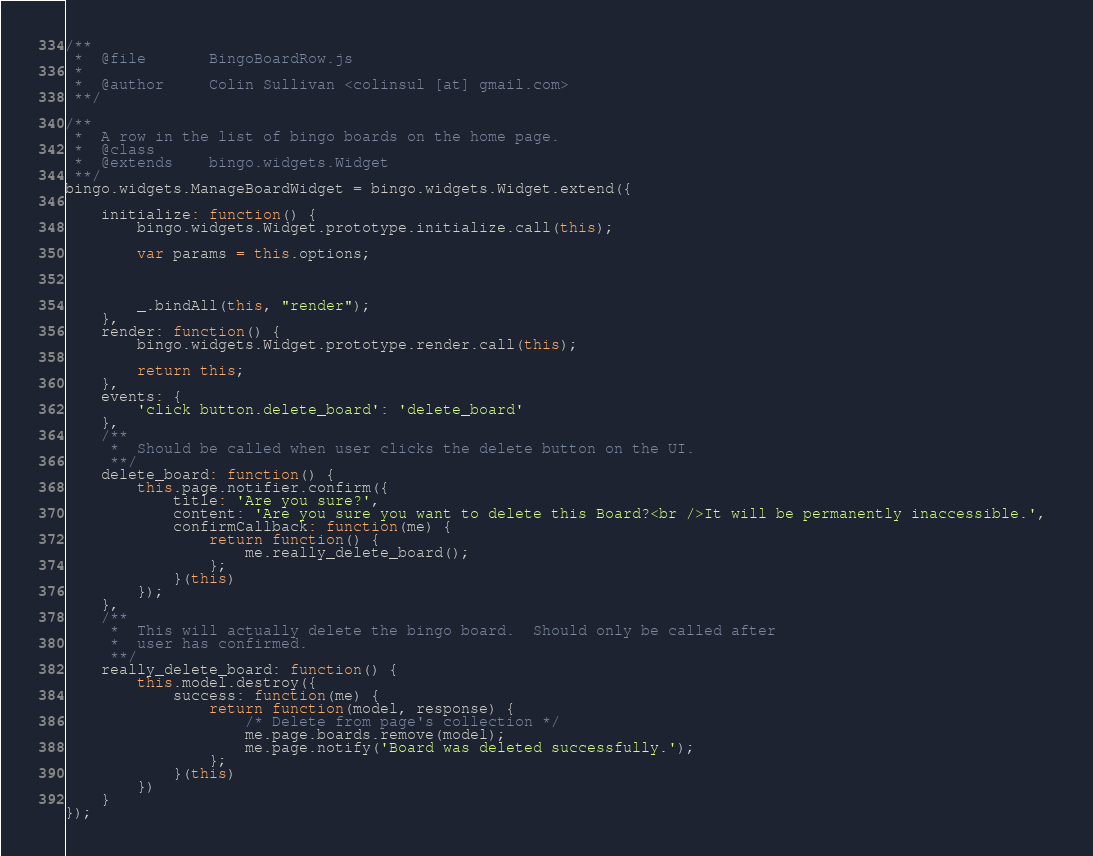Convert code to text. <code><loc_0><loc_0><loc_500><loc_500><_JavaScript_>/**
 *  @file       BingoBoardRow.js
 *  
 *  @author     Colin Sullivan <colinsul [at] gmail.com>
 **/
 
/**
 *  A row in the list of bingo boards on the home page.
 *  @class
 *  @extends    bingo.widgets.Widget
 **/
bingo.widgets.ManageBoardWidget = bingo.widgets.Widget.extend({
    
    initialize: function() {
        bingo.widgets.Widget.prototype.initialize.call(this);

        var params = this.options;
        
        

        _.bindAll(this, "render");
    },
    render: function() {
        bingo.widgets.Widget.prototype.render.call(this);
        
        return this;
    },
    events: {
        'click button.delete_board': 'delete_board'
    }, 
    /**
     *  Should be called when user clicks the delete button on the UI.
     **/
    delete_board: function() {
        this.page.notifier.confirm({
            title: 'Are you sure?', 
            content: 'Are you sure you want to delete this Board?<br />It will be permanently inaccessible.', 
            confirmCallback: function(me) {
                return function() {
                    me.really_delete_board();
                };
            }(this)
        });
    }, 
    /**
     *  This will actually delete the bingo board.  Should only be called after
     *  user has confirmed.
     **/
    really_delete_board: function() {
        this.model.destroy({
            success: function(me) {
                return function(model, response) {
                    /* Delete from page's collection */
                    me.page.boards.remove(model);
                    me.page.notify('Board was deleted successfully.');
                };
            }(this)
        })
    }
});
</code> 